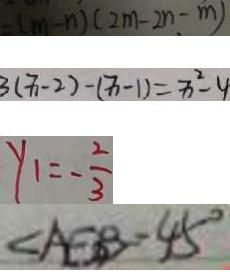<formula> <loc_0><loc_0><loc_500><loc_500>- ( m - n ) ( 2 m - 2 n - m ) 
 3 ( x - 2 ) - ( x - 1 ) = x ^ { 2 } - 4 
 y _ { 1 } = - \frac { 2 } { 3 } 
 \angle A E B = 4 5 ^ { \circ }</formula> 